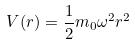<formula> <loc_0><loc_0><loc_500><loc_500>V ( r ) = \frac { 1 } { 2 } m _ { 0 } \omega ^ { 2 } r ^ { 2 }</formula> 